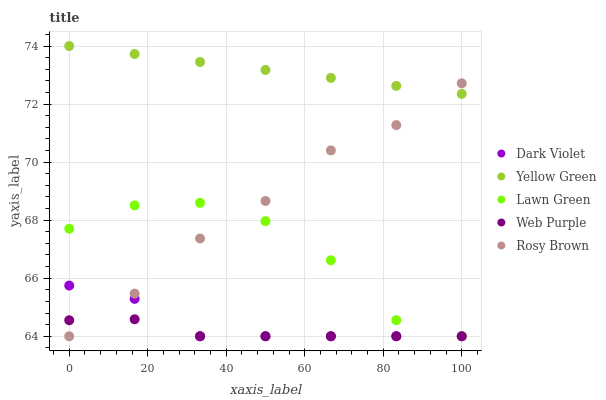Does Web Purple have the minimum area under the curve?
Answer yes or no. Yes. Does Yellow Green have the maximum area under the curve?
Answer yes or no. Yes. Does Rosy Brown have the minimum area under the curve?
Answer yes or no. No. Does Rosy Brown have the maximum area under the curve?
Answer yes or no. No. Is Yellow Green the smoothest?
Answer yes or no. Yes. Is Lawn Green the roughest?
Answer yes or no. Yes. Is Web Purple the smoothest?
Answer yes or no. No. Is Web Purple the roughest?
Answer yes or no. No. Does Lawn Green have the lowest value?
Answer yes or no. Yes. Does Yellow Green have the lowest value?
Answer yes or no. No. Does Yellow Green have the highest value?
Answer yes or no. Yes. Does Rosy Brown have the highest value?
Answer yes or no. No. Is Web Purple less than Yellow Green?
Answer yes or no. Yes. Is Yellow Green greater than Dark Violet?
Answer yes or no. Yes. Does Rosy Brown intersect Dark Violet?
Answer yes or no. Yes. Is Rosy Brown less than Dark Violet?
Answer yes or no. No. Is Rosy Brown greater than Dark Violet?
Answer yes or no. No. Does Web Purple intersect Yellow Green?
Answer yes or no. No. 